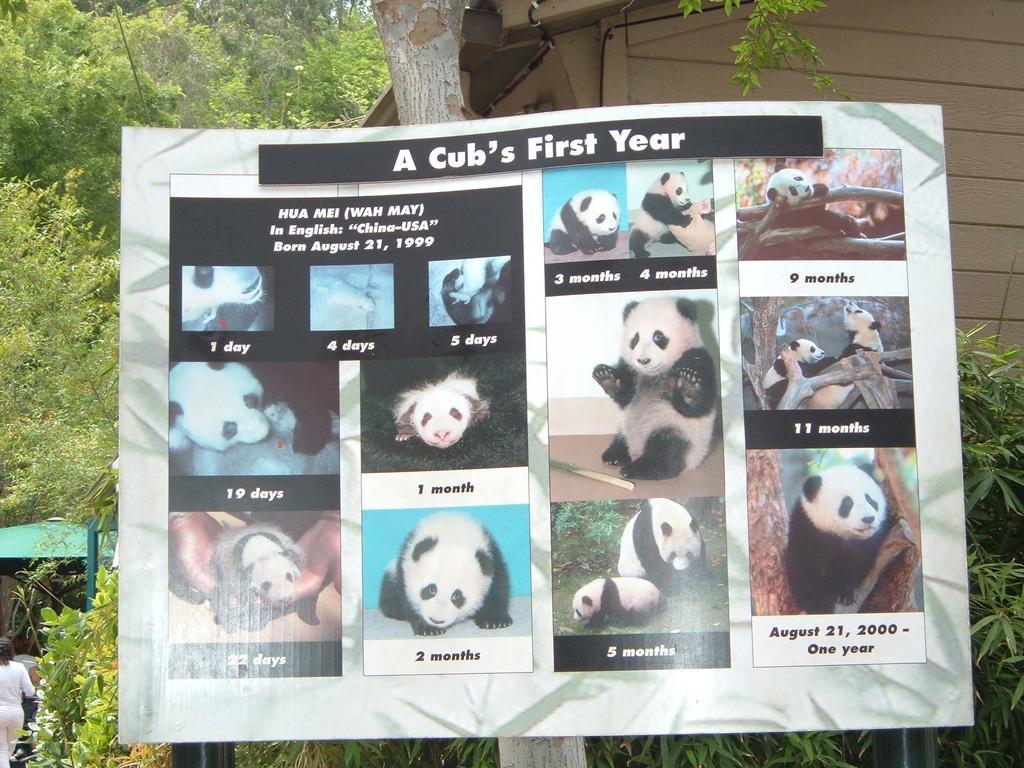Describe this image in one or two sentences. In this image there is a board on a tree. There are pictures of a panda and text on the board. Behind the board there is a house. In the background there are trees. In the bottom left there is a person walking. 